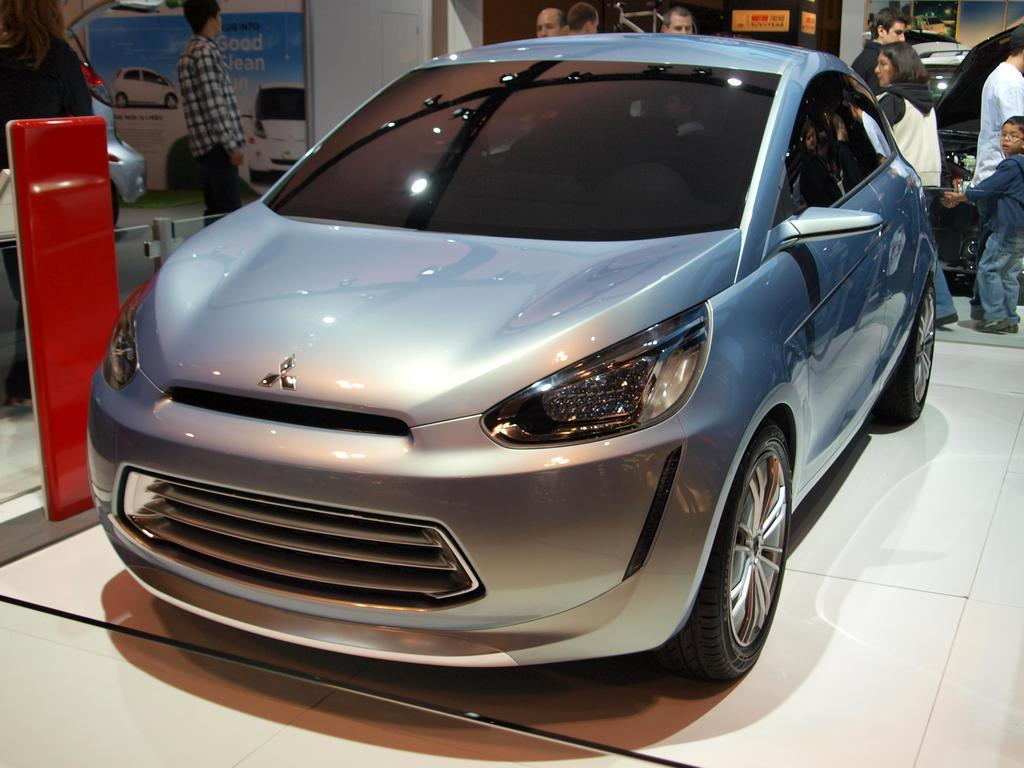What is the main subject in the center of the image? There is a car in the center of the image. Are there any people visible in the image? Yes, there are people behind the car. Can you describe the surrounding environment in the image? There are other cars visible in the image. What additional decorative elements are present in the image? Banners are present with the cars at the top of the image. What type of jeans are the ants wearing in the image? There are no ants or jeans present in the image. 